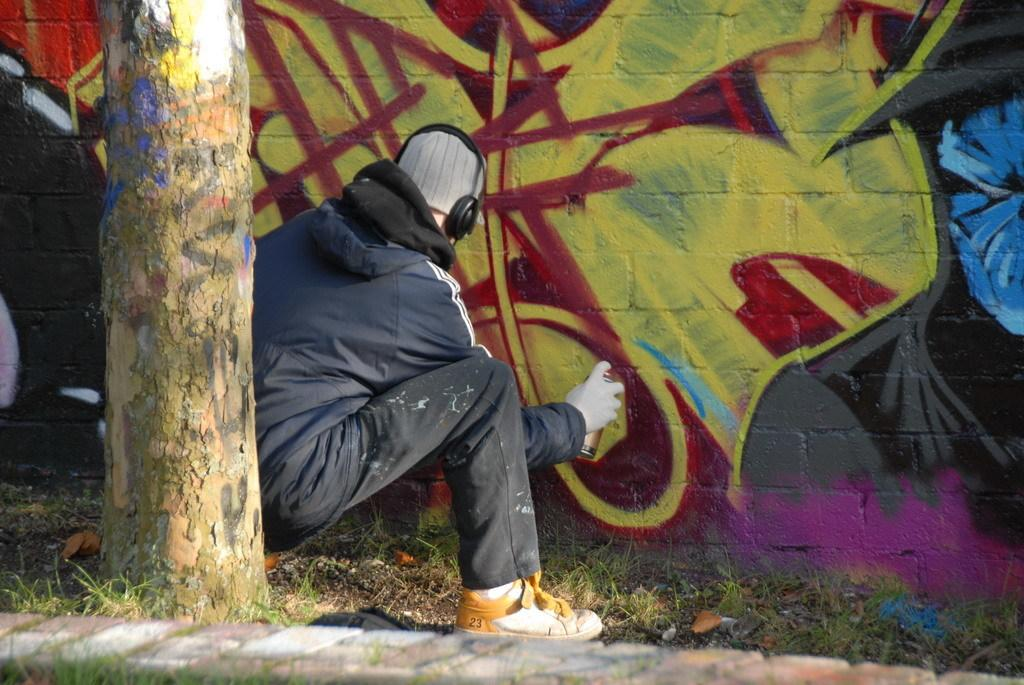What can be seen in the image besides the person? There is a branch, grass, a wall, and graffiti present in the image. What is the person wearing on their head? The person is wearing a headset. What is the person holding in their hand? The person is holding a spray bottle. What is the condition of the wall in the image? The wall has graffiti on it. What type of beast can be seen grazing on the tomatoes in the image? There is no beast or tomatoes present in the image. Is the person in the image in a quiet environment? The image does not provide any information about the noise level in the environment. 